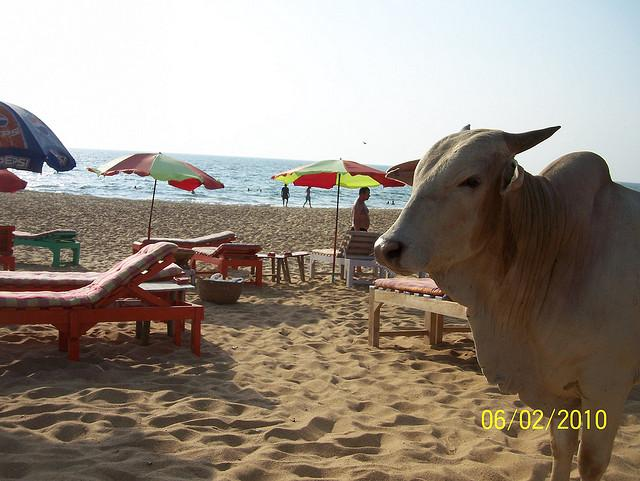Which sentient beings are able to swim? humans 